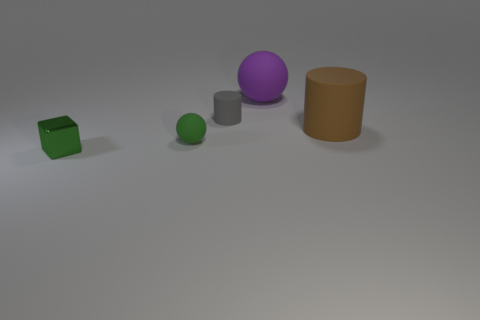What number of green metallic cubes have the same size as the gray rubber object?
Offer a terse response. 1. Does the sphere in front of the brown rubber cylinder have the same size as the matte cylinder that is right of the purple object?
Make the answer very short. No. There is a matte object that is in front of the brown cylinder; how big is it?
Give a very brief answer. Small. There is a object on the left side of the green thing that is on the right side of the tiny green metal thing; what is its size?
Provide a succinct answer. Small. What is the material of the green sphere that is the same size as the gray matte cylinder?
Give a very brief answer. Rubber. There is a tiny block; are there any small metallic things behind it?
Keep it short and to the point. No. Is the number of gray rubber objects on the right side of the purple ball the same as the number of green rubber things?
Keep it short and to the point. No. There is a purple thing that is the same size as the brown matte object; what is its shape?
Provide a succinct answer. Sphere. What is the material of the gray cylinder?
Offer a terse response. Rubber. What color is the object that is behind the small ball and left of the purple rubber thing?
Provide a short and direct response. Gray. 